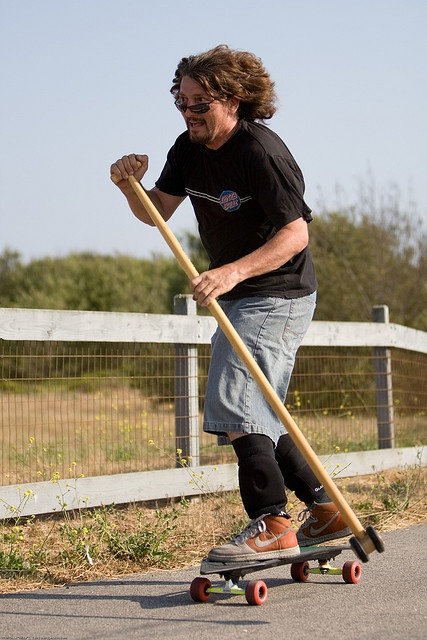Describe the objects in this image and their specific colors. I can see people in lightgray, black, gray, darkgray, and maroon tones and skateboard in lightgray, black, gray, maroon, and darkgray tones in this image. 